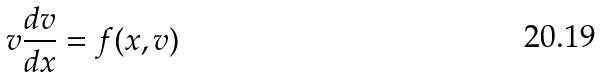<formula> <loc_0><loc_0><loc_500><loc_500>v \frac { d v } { d x } = f ( x , v )</formula> 